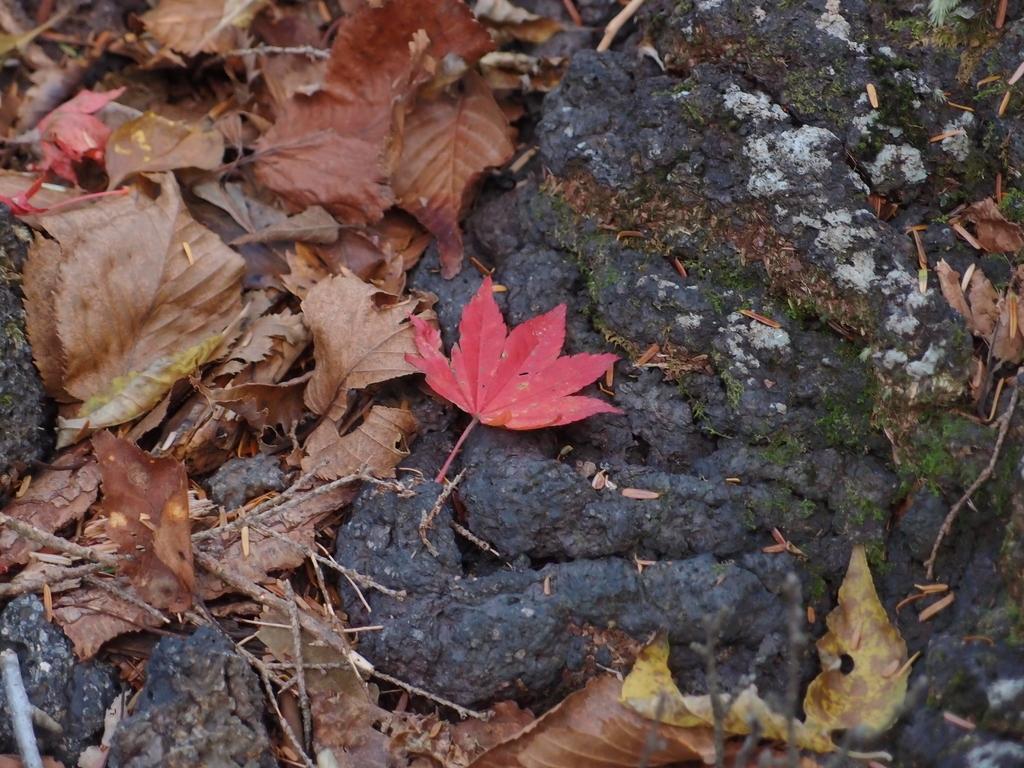How would you summarize this image in a sentence or two? In this image I can see there are dried leaves. 